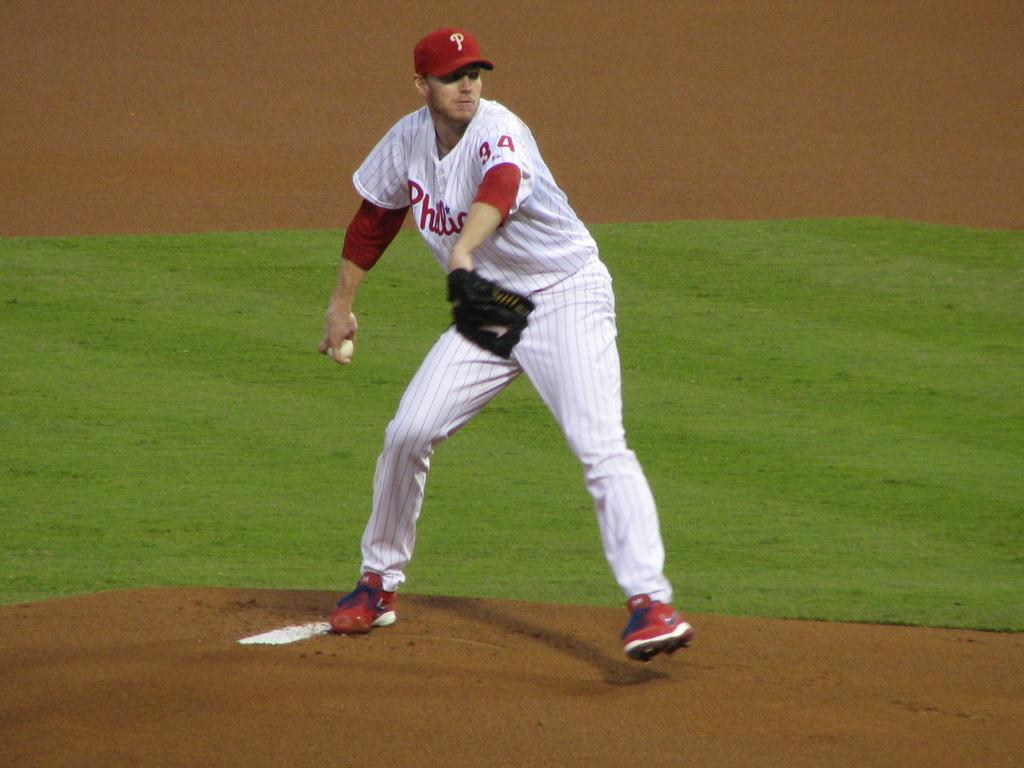<image>
Create a compact narrative representing the image presented. The baseball player is wearing jersey number 44. 